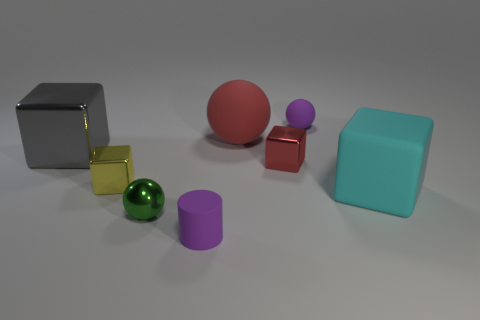Subtract all cyan cylinders. Subtract all green spheres. How many cylinders are left? 1 Add 1 red cubes. How many objects exist? 9 Subtract all cylinders. How many objects are left? 7 Add 3 large objects. How many large objects are left? 6 Add 7 blue metallic cubes. How many blue metallic cubes exist? 7 Subtract 0 yellow cylinders. How many objects are left? 8 Subtract all shiny spheres. Subtract all yellow metallic blocks. How many objects are left? 6 